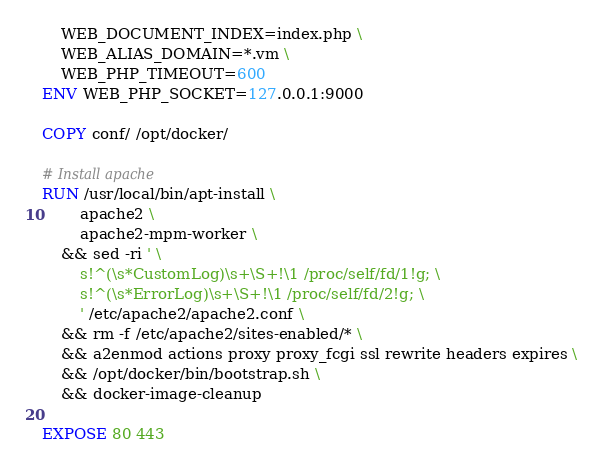Convert code to text. <code><loc_0><loc_0><loc_500><loc_500><_Dockerfile_>    WEB_DOCUMENT_INDEX=index.php \
    WEB_ALIAS_DOMAIN=*.vm \
    WEB_PHP_TIMEOUT=600
ENV WEB_PHP_SOCKET=127.0.0.1:9000

COPY conf/ /opt/docker/

# Install apache
RUN /usr/local/bin/apt-install \
        apache2 \
        apache2-mpm-worker \
	&& sed -ri ' \
		s!^(\s*CustomLog)\s+\S+!\1 /proc/self/fd/1!g; \
		s!^(\s*ErrorLog)\s+\S+!\1 /proc/self/fd/2!g; \
		' /etc/apache2/apache2.conf \
	&& rm -f /etc/apache2/sites-enabled/* \
	&& a2enmod actions proxy proxy_fcgi ssl rewrite headers expires \
	&& /opt/docker/bin/bootstrap.sh \
    && docker-image-cleanup

EXPOSE 80 443
</code> 